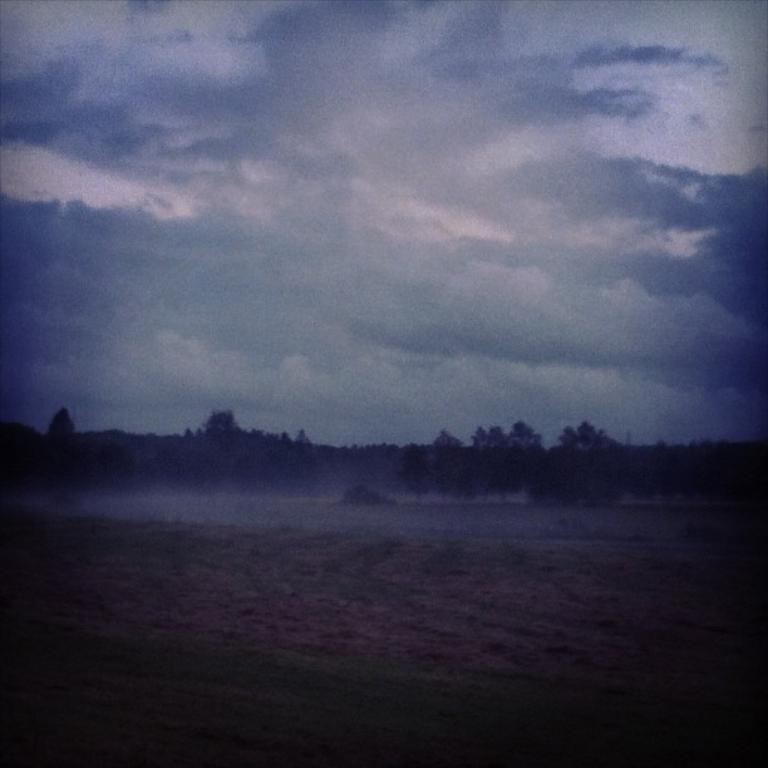What can be seen in the background of the image? There are trees in the background of the image. How would you describe the sky in the image? The sky is cloudy in the image. Can you describe the overall quality of the image? The image is blurry. How many trucks are visible in the image? There are no trucks present in the image. What type of texture can be seen on the trees in the image? The image is blurry, so it is difficult to discern the texture of the trees. 